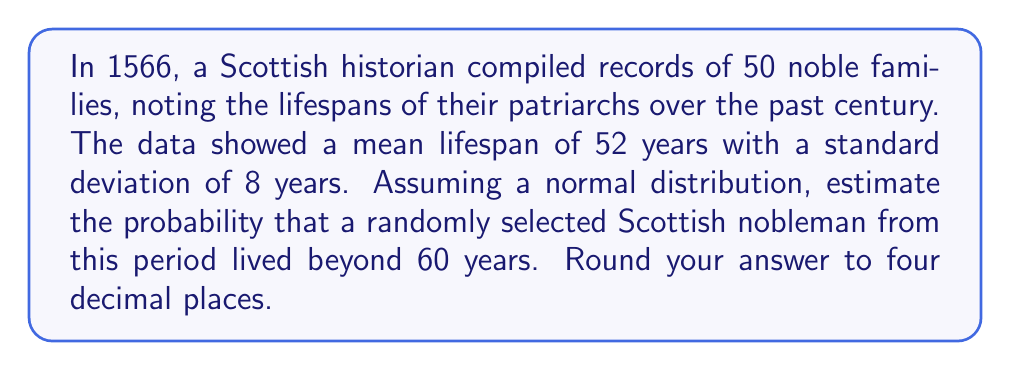Could you help me with this problem? To solve this problem, we need to use the z-score formula and the standard normal distribution table. Let's break it down step-by-step:

1) We're given:
   - Mean ($\mu$) = 52 years
   - Standard deviation ($\sigma$) = 8 years
   - We want to find P(X > 60), where X is the lifespan

2) Calculate the z-score for 60 years:
   $$z = \frac{x - \mu}{\sigma} = \frac{60 - 52}{8} = 1$$

3) We need to find P(Z > 1), where Z is the standard normal variable

4) Using the standard normal distribution table:
   P(Z < 1) = 0.8413

5) Therefore:
   P(Z > 1) = 1 - P(Z < 1) = 1 - 0.8413 = 0.1587

6) Rounding to four decimal places: 0.1587

This means there's approximately a 15.87% chance that a randomly selected Scottish nobleman from this period lived beyond 60 years.
Answer: 0.1587 